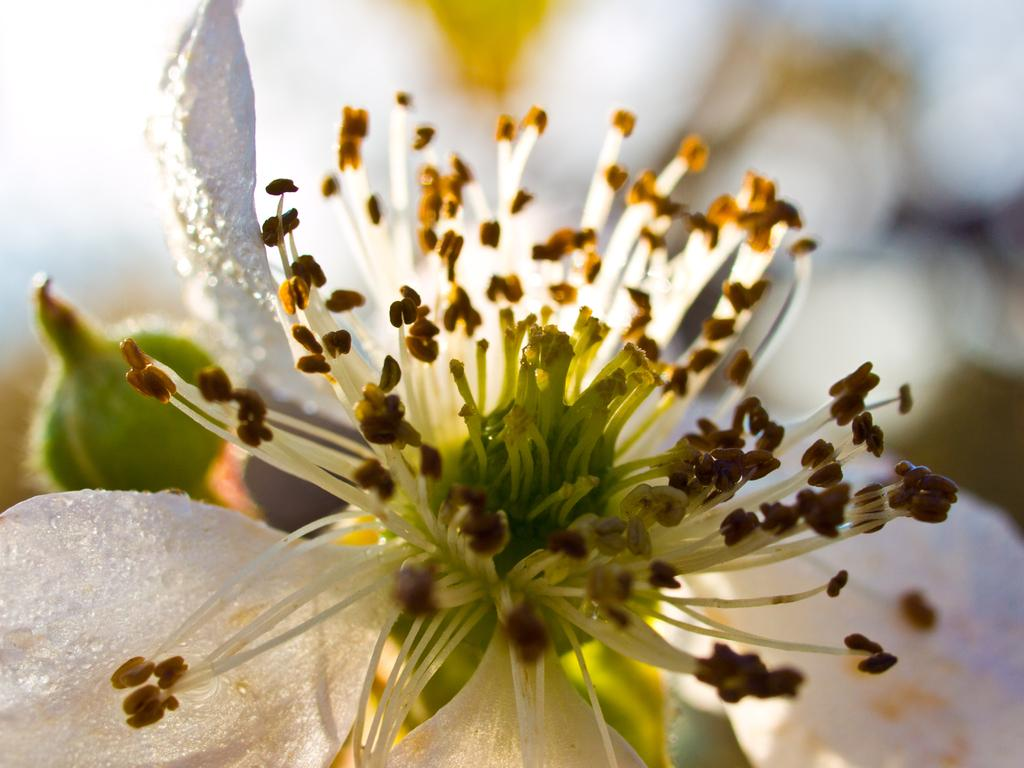What is the main subject of the image? There is a flower in the image. Can you describe the flower's stage of growth? There is a bud in the image, which suggests the flower is in its early stage of growth. What colors are present in the background of the image? The background of the image is blue and white. How many rings can be seen on the doctor's finger in the image? There is no doctor or rings present in the image; it features a flower and a blue and white background. 